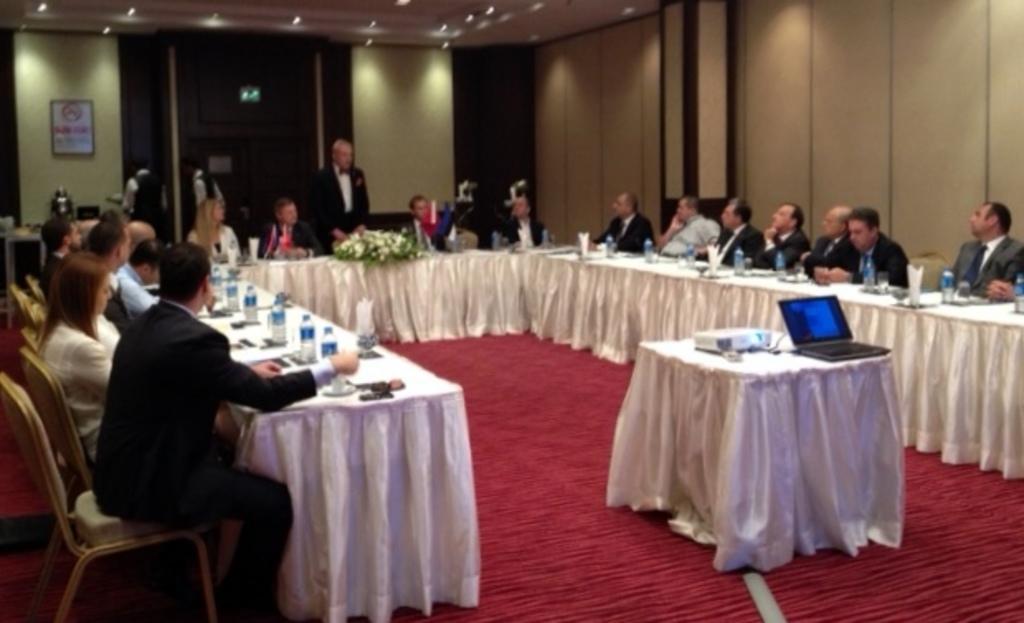In one or two sentences, can you explain what this image depicts? As we can see in the image there is a wall, photo frame, few people sitting on chairs and tables. On tables there are bottles, flowers, tissues, laptop, projector and white color cloth. 